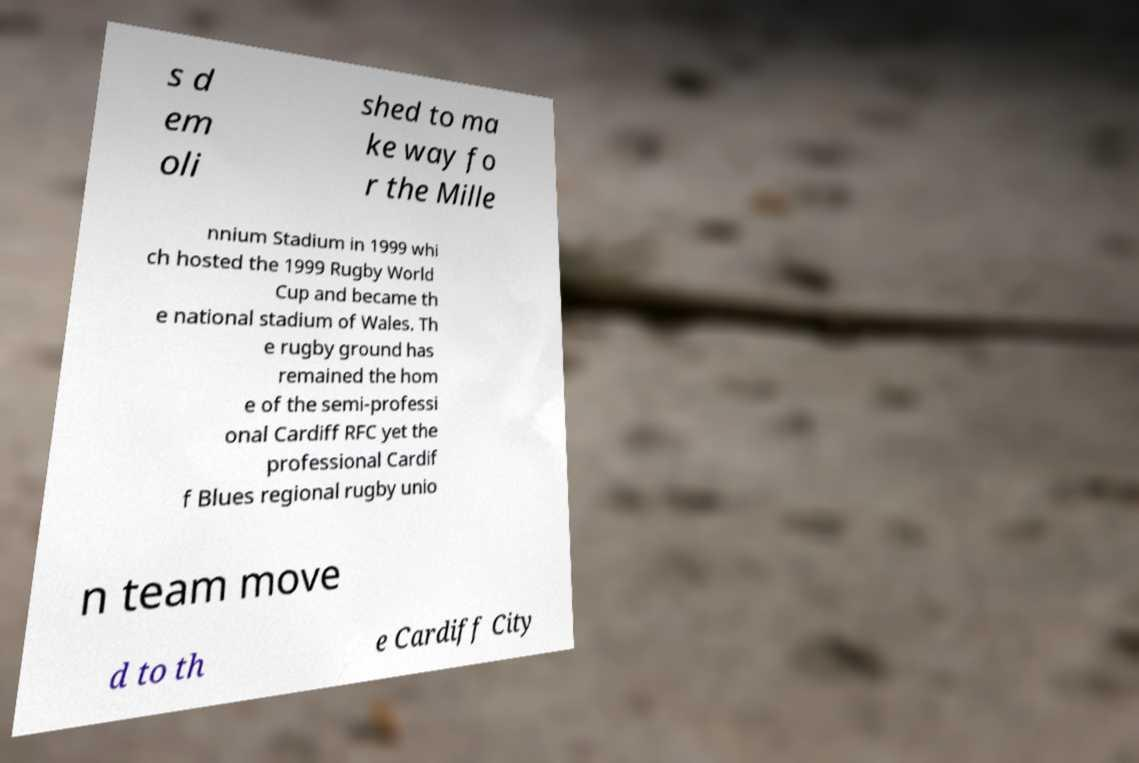Can you read and provide the text displayed in the image?This photo seems to have some interesting text. Can you extract and type it out for me? s d em oli shed to ma ke way fo r the Mille nnium Stadium in 1999 whi ch hosted the 1999 Rugby World Cup and became th e national stadium of Wales. Th e rugby ground has remained the hom e of the semi-professi onal Cardiff RFC yet the professional Cardif f Blues regional rugby unio n team move d to th e Cardiff City 